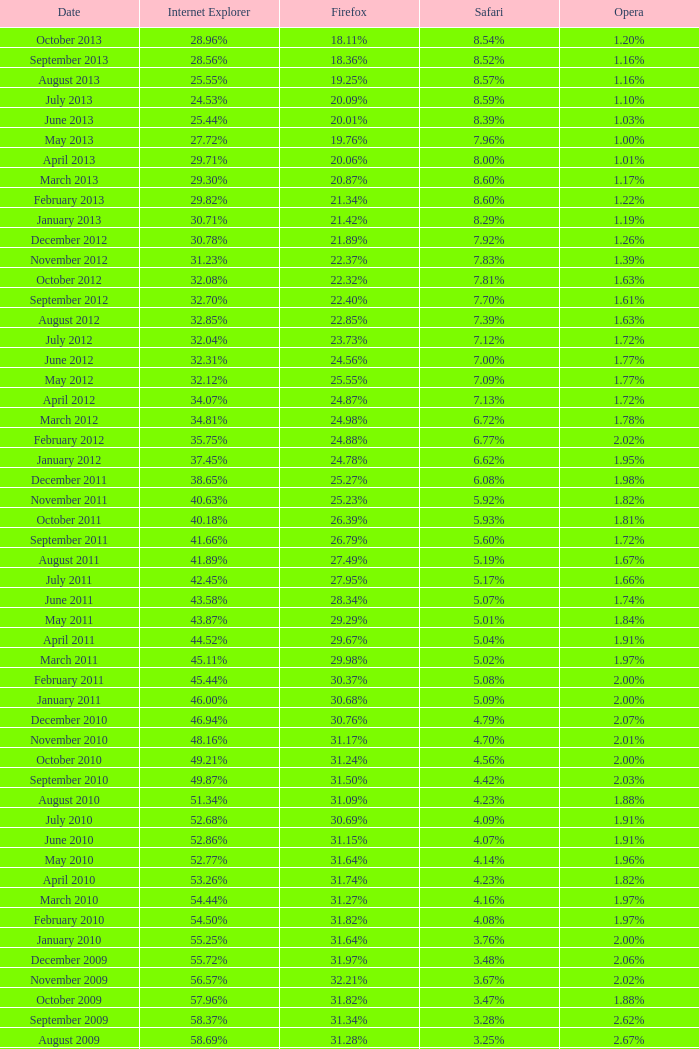Help me parse the entirety of this table. {'header': ['Date', 'Internet Explorer', 'Firefox', 'Safari', 'Opera'], 'rows': [['October 2013', '28.96%', '18.11%', '8.54%', '1.20%'], ['September 2013', '28.56%', '18.36%', '8.52%', '1.16%'], ['August 2013', '25.55%', '19.25%', '8.57%', '1.16%'], ['July 2013', '24.53%', '20.09%', '8.59%', '1.10%'], ['June 2013', '25.44%', '20.01%', '8.39%', '1.03%'], ['May 2013', '27.72%', '19.76%', '7.96%', '1.00%'], ['April 2013', '29.71%', '20.06%', '8.00%', '1.01%'], ['March 2013', '29.30%', '20.87%', '8.60%', '1.17%'], ['February 2013', '29.82%', '21.34%', '8.60%', '1.22%'], ['January 2013', '30.71%', '21.42%', '8.29%', '1.19%'], ['December 2012', '30.78%', '21.89%', '7.92%', '1.26%'], ['November 2012', '31.23%', '22.37%', '7.83%', '1.39%'], ['October 2012', '32.08%', '22.32%', '7.81%', '1.63%'], ['September 2012', '32.70%', '22.40%', '7.70%', '1.61%'], ['August 2012', '32.85%', '22.85%', '7.39%', '1.63%'], ['July 2012', '32.04%', '23.73%', '7.12%', '1.72%'], ['June 2012', '32.31%', '24.56%', '7.00%', '1.77%'], ['May 2012', '32.12%', '25.55%', '7.09%', '1.77%'], ['April 2012', '34.07%', '24.87%', '7.13%', '1.72%'], ['March 2012', '34.81%', '24.98%', '6.72%', '1.78%'], ['February 2012', '35.75%', '24.88%', '6.77%', '2.02%'], ['January 2012', '37.45%', '24.78%', '6.62%', '1.95%'], ['December 2011', '38.65%', '25.27%', '6.08%', '1.98%'], ['November 2011', '40.63%', '25.23%', '5.92%', '1.82%'], ['October 2011', '40.18%', '26.39%', '5.93%', '1.81%'], ['September 2011', '41.66%', '26.79%', '5.60%', '1.72%'], ['August 2011', '41.89%', '27.49%', '5.19%', '1.67%'], ['July 2011', '42.45%', '27.95%', '5.17%', '1.66%'], ['June 2011', '43.58%', '28.34%', '5.07%', '1.74%'], ['May 2011', '43.87%', '29.29%', '5.01%', '1.84%'], ['April 2011', '44.52%', '29.67%', '5.04%', '1.91%'], ['March 2011', '45.11%', '29.98%', '5.02%', '1.97%'], ['February 2011', '45.44%', '30.37%', '5.08%', '2.00%'], ['January 2011', '46.00%', '30.68%', '5.09%', '2.00%'], ['December 2010', '46.94%', '30.76%', '4.79%', '2.07%'], ['November 2010', '48.16%', '31.17%', '4.70%', '2.01%'], ['October 2010', '49.21%', '31.24%', '4.56%', '2.00%'], ['September 2010', '49.87%', '31.50%', '4.42%', '2.03%'], ['August 2010', '51.34%', '31.09%', '4.23%', '1.88%'], ['July 2010', '52.68%', '30.69%', '4.09%', '1.91%'], ['June 2010', '52.86%', '31.15%', '4.07%', '1.91%'], ['May 2010', '52.77%', '31.64%', '4.14%', '1.96%'], ['April 2010', '53.26%', '31.74%', '4.23%', '1.82%'], ['March 2010', '54.44%', '31.27%', '4.16%', '1.97%'], ['February 2010', '54.50%', '31.82%', '4.08%', '1.97%'], ['January 2010', '55.25%', '31.64%', '3.76%', '2.00%'], ['December 2009', '55.72%', '31.97%', '3.48%', '2.06%'], ['November 2009', '56.57%', '32.21%', '3.67%', '2.02%'], ['October 2009', '57.96%', '31.82%', '3.47%', '1.88%'], ['September 2009', '58.37%', '31.34%', '3.28%', '2.62%'], ['August 2009', '58.69%', '31.28%', '3.25%', '2.67%'], ['July 2009', '60.11%', '30.50%', '3.02%', '2.64%'], ['June 2009', '59.49%', '30.26%', '2.91%', '3.46%'], ['May 2009', '62.09%', '28.75%', '2.65%', '3.23%'], ['April 2009', '61.88%', '29.67%', '2.75%', '2.96%'], ['March 2009', '62.52%', '29.40%', '2.73%', '2.94%'], ['February 2009', '64.43%', '27.85%', '2.59%', '2.95%'], ['January 2009', '65.41%', '27.03%', '2.57%', '2.92%'], ['December 2008', '67.84%', '25.23%', '2.41%', '2.83%'], ['November 2008', '68.14%', '25.27%', '2.49%', '3.01%'], ['October 2008', '67.68%', '25.54%', '2.91%', '2.69%'], ['September2008', '67.16%', '25.77%', '3.00%', '2.86%'], ['August 2008', '68.91%', '26.08%', '2.99%', '1.83%'], ['July 2008', '68.57%', '26.14%', '3.30%', '1.78%']]} What percentage of browsers were using Opera in October 2010? 2.00%. 